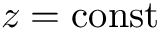<formula> <loc_0><loc_0><loc_500><loc_500>z = c o n s t</formula> 